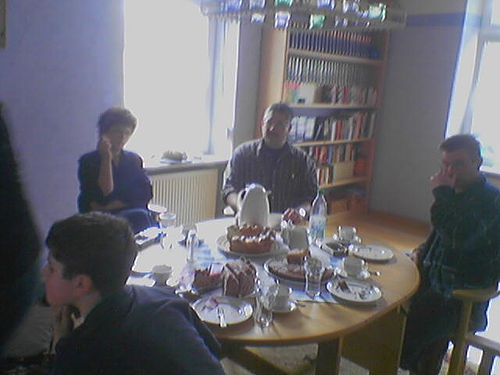Describe the objects in this image and their specific colors. I can see dining table in gray, darkgray, and lightgray tones, people in gray and black tones, people in gray, black, and navy tones, people in gray, black, and darkgray tones, and people in gray, navy, and black tones in this image. 